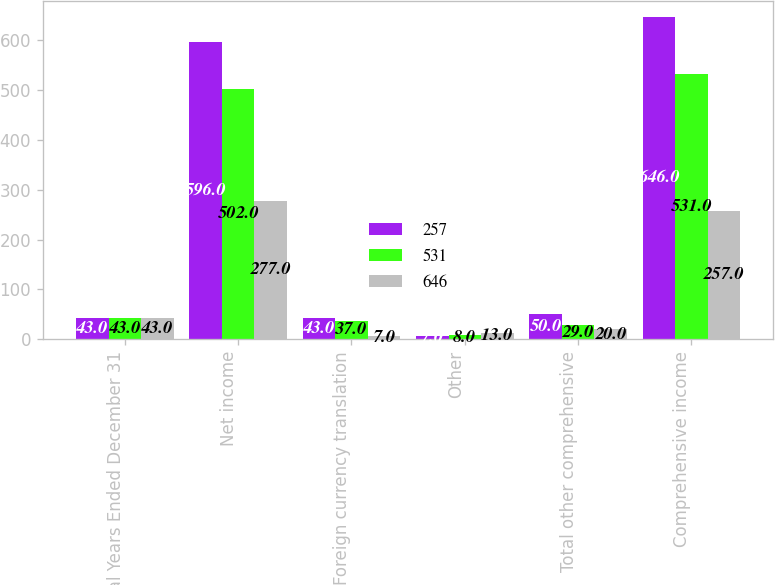Convert chart to OTSL. <chart><loc_0><loc_0><loc_500><loc_500><stacked_bar_chart><ecel><fcel>Fiscal Years Ended December 31<fcel>Net income<fcel>Foreign currency translation<fcel>Other<fcel>Total other comprehensive<fcel>Comprehensive income<nl><fcel>257<fcel>43<fcel>596<fcel>43<fcel>7<fcel>50<fcel>646<nl><fcel>531<fcel>43<fcel>502<fcel>37<fcel>8<fcel>29<fcel>531<nl><fcel>646<fcel>43<fcel>277<fcel>7<fcel>13<fcel>20<fcel>257<nl></chart> 